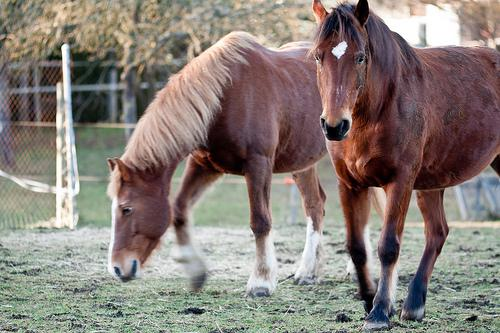Question: how many horses are there?
Choices:
A. 3.
B. 2.
C. 4.
D. 5.
Answer with the letter. Answer: B Question: where are the animals?
Choices:
A. In a field.
B. On a boat.
C. In the zoo.
D. Over there.
Answer with the letter. Answer: A Question: what animals are seen?
Choices:
A. Cows.
B. Chickens.
C. Horses.
D. Ducks.
Answer with the letter. Answer: C Question: what is behind the horses?
Choices:
A. A car.
B. Some people.
C. A river.
D. A tree.
Answer with the letter. Answer: D Question: when was this taken?
Choices:
A. At night.
B. Last year.
C. Summer.
D. During the day.
Answer with the letter. Answer: D 